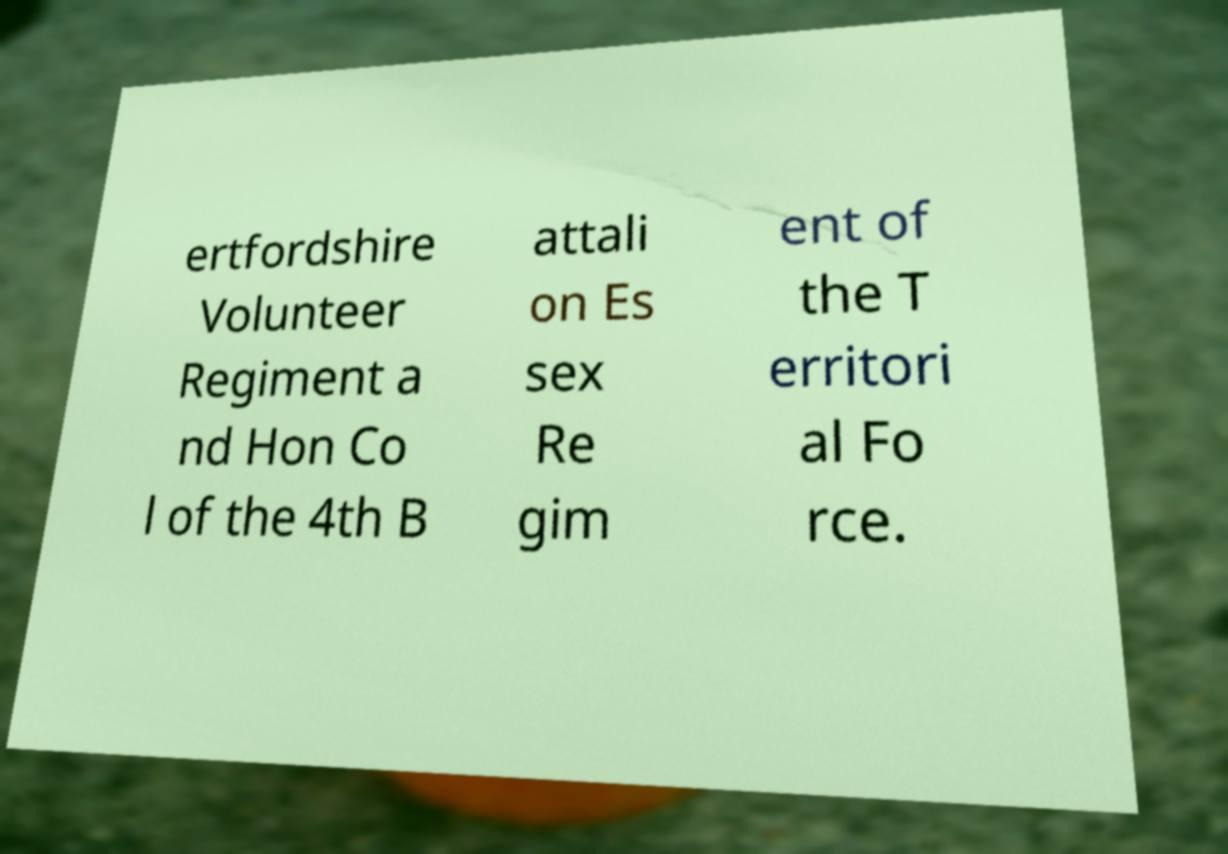What messages or text are displayed in this image? I need them in a readable, typed format. ertfordshire Volunteer Regiment a nd Hon Co l of the 4th B attali on Es sex Re gim ent of the T erritori al Fo rce. 